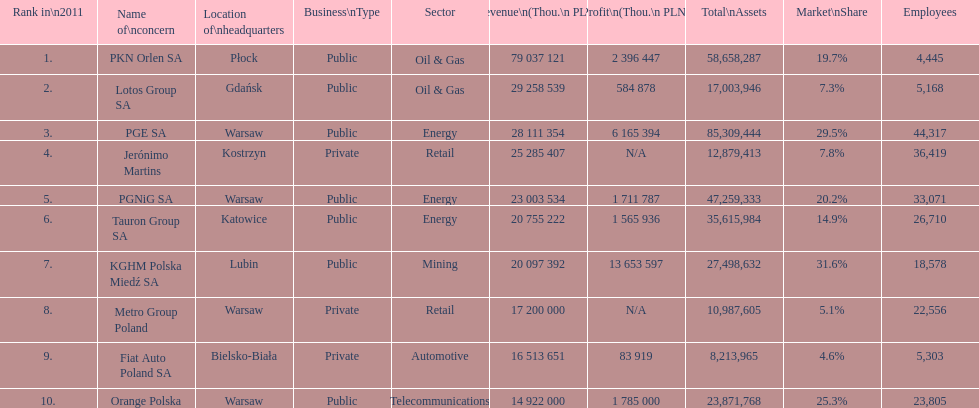Which company had the most employees? PGE SA. 